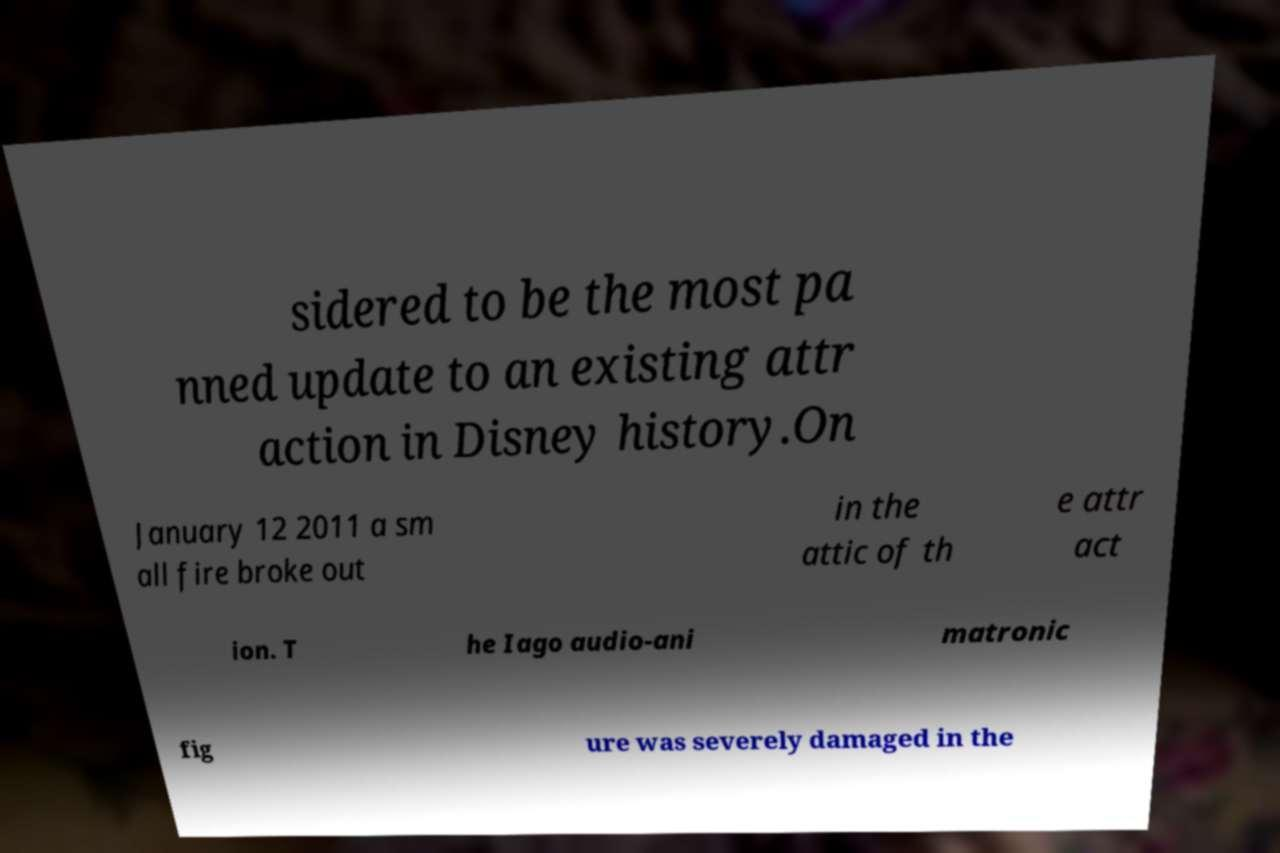Could you extract and type out the text from this image? sidered to be the most pa nned update to an existing attr action in Disney history.On January 12 2011 a sm all fire broke out in the attic of th e attr act ion. T he Iago audio-ani matronic fig ure was severely damaged in the 